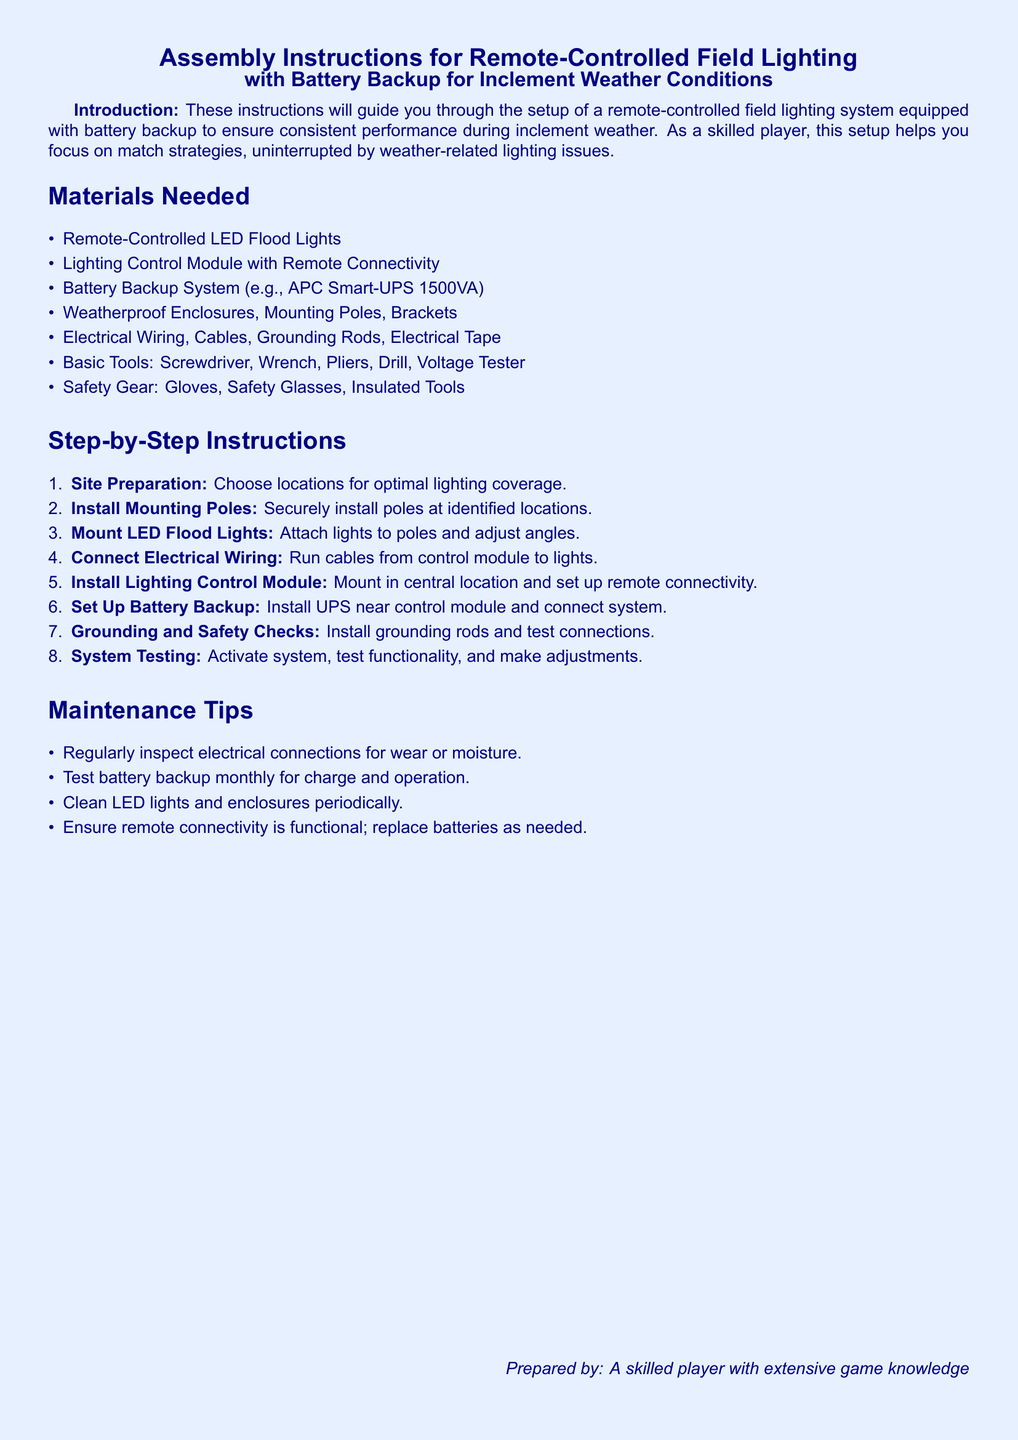What is the purpose of these instructions? The instructions guide users through the setup of a remote-controlled field lighting system equipped with battery backup for inclement weather.
Answer: Setup guidance What type of battery backup system is recommended? The instructions specify using an APC Smart-UPS 1500VA as an example for the battery backup system.
Answer: APC Smart-UPS 1500VA How many steps are provided in the assembly instructions? There are eight steps outlined in the step-by-step instructions section of the document.
Answer: Eight What tools are listed under basic tools? The basic tools listed include Screwdriver, Wrench, Pliers, Drill, and Voltage Tester.
Answer: Screwdriver, Wrench, Pliers, Drill, Voltage Tester Name one maintenance tip mentioned in the document. One maintenance tip is to regularly inspect electrical connections for wear or moisture.
Answer: Inspect connections What is the color of the page background? The page background is colored light blue as specified in the document.
Answer: Light blue Where should the lighting control module be installed? The lighting control module should be mounted in a central location as indicated in the setup instructions.
Answer: Central location What should be done to the LED lights periodically? The instructions recommend cleaning LED lights and enclosures periodically.
Answer: Clean lights Which type of lighting is used in this setup? The document specifies using Remote-Controlled LED Flood Lights for the lighting setup.
Answer: LED Flood Lights 